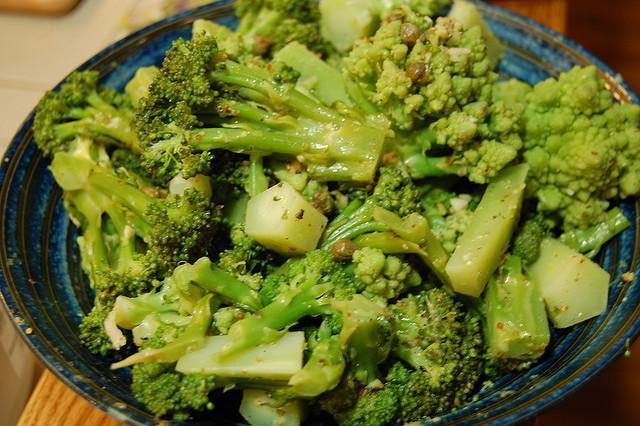How many broccolis are in the picture?
Give a very brief answer. 3. 